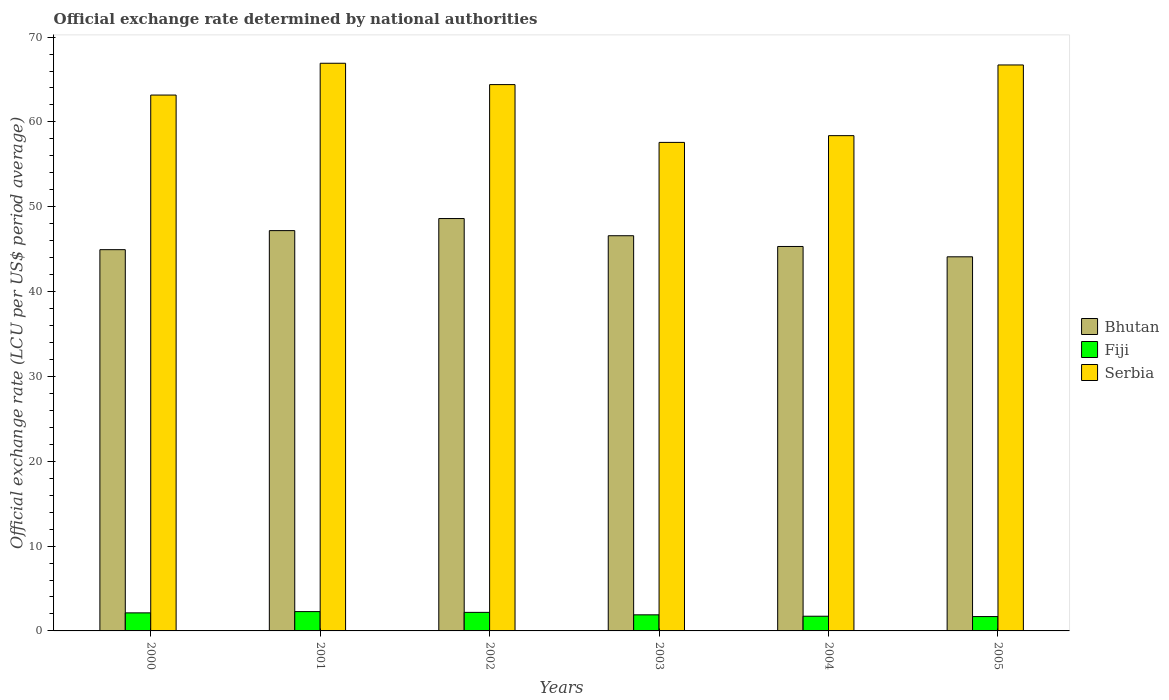How many bars are there on the 3rd tick from the left?
Offer a very short reply. 3. How many bars are there on the 5th tick from the right?
Provide a succinct answer. 3. What is the label of the 3rd group of bars from the left?
Keep it short and to the point. 2002. In how many cases, is the number of bars for a given year not equal to the number of legend labels?
Give a very brief answer. 0. What is the official exchange rate in Fiji in 2004?
Your answer should be very brief. 1.73. Across all years, what is the maximum official exchange rate in Serbia?
Your answer should be very brief. 66.91. Across all years, what is the minimum official exchange rate in Bhutan?
Make the answer very short. 44.1. In which year was the official exchange rate in Serbia maximum?
Your answer should be compact. 2001. What is the total official exchange rate in Serbia in the graph?
Ensure brevity in your answer.  377.16. What is the difference between the official exchange rate in Bhutan in 2002 and that in 2005?
Offer a terse response. 4.51. What is the difference between the official exchange rate in Serbia in 2005 and the official exchange rate in Fiji in 2004?
Your response must be concise. 64.98. What is the average official exchange rate in Serbia per year?
Give a very brief answer. 62.86. In the year 2001, what is the difference between the official exchange rate in Serbia and official exchange rate in Fiji?
Offer a very short reply. 64.64. In how many years, is the official exchange rate in Fiji greater than 18 LCU?
Offer a very short reply. 0. What is the ratio of the official exchange rate in Serbia in 2000 to that in 2005?
Give a very brief answer. 0.95. Is the official exchange rate in Serbia in 2000 less than that in 2004?
Your answer should be very brief. No. Is the difference between the official exchange rate in Serbia in 2000 and 2001 greater than the difference between the official exchange rate in Fiji in 2000 and 2001?
Provide a succinct answer. No. What is the difference between the highest and the second highest official exchange rate in Bhutan?
Your answer should be compact. 1.42. What is the difference between the highest and the lowest official exchange rate in Bhutan?
Ensure brevity in your answer.  4.51. In how many years, is the official exchange rate in Fiji greater than the average official exchange rate in Fiji taken over all years?
Your response must be concise. 3. Is the sum of the official exchange rate in Bhutan in 2003 and 2004 greater than the maximum official exchange rate in Serbia across all years?
Provide a short and direct response. Yes. What does the 2nd bar from the left in 2002 represents?
Keep it short and to the point. Fiji. What does the 2nd bar from the right in 2005 represents?
Your response must be concise. Fiji. What is the difference between two consecutive major ticks on the Y-axis?
Your answer should be very brief. 10. How many legend labels are there?
Provide a succinct answer. 3. What is the title of the graph?
Offer a terse response. Official exchange rate determined by national authorities. What is the label or title of the Y-axis?
Your answer should be compact. Official exchange rate (LCU per US$ period average). What is the Official exchange rate (LCU per US$ period average) in Bhutan in 2000?
Ensure brevity in your answer.  44.94. What is the Official exchange rate (LCU per US$ period average) in Fiji in 2000?
Offer a very short reply. 2.13. What is the Official exchange rate (LCU per US$ period average) of Serbia in 2000?
Provide a short and direct response. 63.17. What is the Official exchange rate (LCU per US$ period average) of Bhutan in 2001?
Ensure brevity in your answer.  47.19. What is the Official exchange rate (LCU per US$ period average) in Fiji in 2001?
Offer a terse response. 2.28. What is the Official exchange rate (LCU per US$ period average) in Serbia in 2001?
Provide a short and direct response. 66.91. What is the Official exchange rate (LCU per US$ period average) of Bhutan in 2002?
Your answer should be very brief. 48.61. What is the Official exchange rate (LCU per US$ period average) in Fiji in 2002?
Offer a terse response. 2.19. What is the Official exchange rate (LCU per US$ period average) of Serbia in 2002?
Ensure brevity in your answer.  64.4. What is the Official exchange rate (LCU per US$ period average) of Bhutan in 2003?
Offer a very short reply. 46.58. What is the Official exchange rate (LCU per US$ period average) in Fiji in 2003?
Your answer should be compact. 1.9. What is the Official exchange rate (LCU per US$ period average) of Serbia in 2003?
Your answer should be very brief. 57.59. What is the Official exchange rate (LCU per US$ period average) of Bhutan in 2004?
Keep it short and to the point. 45.32. What is the Official exchange rate (LCU per US$ period average) in Fiji in 2004?
Make the answer very short. 1.73. What is the Official exchange rate (LCU per US$ period average) of Serbia in 2004?
Ensure brevity in your answer.  58.38. What is the Official exchange rate (LCU per US$ period average) in Bhutan in 2005?
Provide a short and direct response. 44.1. What is the Official exchange rate (LCU per US$ period average) of Fiji in 2005?
Offer a very short reply. 1.69. What is the Official exchange rate (LCU per US$ period average) in Serbia in 2005?
Ensure brevity in your answer.  66.71. Across all years, what is the maximum Official exchange rate (LCU per US$ period average) of Bhutan?
Your response must be concise. 48.61. Across all years, what is the maximum Official exchange rate (LCU per US$ period average) of Fiji?
Your answer should be compact. 2.28. Across all years, what is the maximum Official exchange rate (LCU per US$ period average) in Serbia?
Give a very brief answer. 66.91. Across all years, what is the minimum Official exchange rate (LCU per US$ period average) of Bhutan?
Give a very brief answer. 44.1. Across all years, what is the minimum Official exchange rate (LCU per US$ period average) of Fiji?
Ensure brevity in your answer.  1.69. Across all years, what is the minimum Official exchange rate (LCU per US$ period average) of Serbia?
Your answer should be compact. 57.59. What is the total Official exchange rate (LCU per US$ period average) in Bhutan in the graph?
Give a very brief answer. 276.74. What is the total Official exchange rate (LCU per US$ period average) in Fiji in the graph?
Offer a terse response. 11.91. What is the total Official exchange rate (LCU per US$ period average) in Serbia in the graph?
Provide a short and direct response. 377.16. What is the difference between the Official exchange rate (LCU per US$ period average) in Bhutan in 2000 and that in 2001?
Your answer should be very brief. -2.24. What is the difference between the Official exchange rate (LCU per US$ period average) of Fiji in 2000 and that in 2001?
Keep it short and to the point. -0.15. What is the difference between the Official exchange rate (LCU per US$ period average) in Serbia in 2000 and that in 2001?
Make the answer very short. -3.75. What is the difference between the Official exchange rate (LCU per US$ period average) in Bhutan in 2000 and that in 2002?
Give a very brief answer. -3.67. What is the difference between the Official exchange rate (LCU per US$ period average) in Fiji in 2000 and that in 2002?
Your response must be concise. -0.06. What is the difference between the Official exchange rate (LCU per US$ period average) in Serbia in 2000 and that in 2002?
Your response must be concise. -1.23. What is the difference between the Official exchange rate (LCU per US$ period average) in Bhutan in 2000 and that in 2003?
Provide a short and direct response. -1.64. What is the difference between the Official exchange rate (LCU per US$ period average) of Fiji in 2000 and that in 2003?
Your answer should be compact. 0.23. What is the difference between the Official exchange rate (LCU per US$ period average) in Serbia in 2000 and that in 2003?
Offer a terse response. 5.58. What is the difference between the Official exchange rate (LCU per US$ period average) in Bhutan in 2000 and that in 2004?
Offer a terse response. -0.37. What is the difference between the Official exchange rate (LCU per US$ period average) in Fiji in 2000 and that in 2004?
Provide a succinct answer. 0.4. What is the difference between the Official exchange rate (LCU per US$ period average) in Serbia in 2000 and that in 2004?
Offer a terse response. 4.78. What is the difference between the Official exchange rate (LCU per US$ period average) of Bhutan in 2000 and that in 2005?
Give a very brief answer. 0.84. What is the difference between the Official exchange rate (LCU per US$ period average) of Fiji in 2000 and that in 2005?
Make the answer very short. 0.44. What is the difference between the Official exchange rate (LCU per US$ period average) of Serbia in 2000 and that in 2005?
Provide a short and direct response. -3.55. What is the difference between the Official exchange rate (LCU per US$ period average) of Bhutan in 2001 and that in 2002?
Offer a terse response. -1.42. What is the difference between the Official exchange rate (LCU per US$ period average) in Fiji in 2001 and that in 2002?
Keep it short and to the point. 0.09. What is the difference between the Official exchange rate (LCU per US$ period average) of Serbia in 2001 and that in 2002?
Offer a very short reply. 2.52. What is the difference between the Official exchange rate (LCU per US$ period average) in Bhutan in 2001 and that in 2003?
Your answer should be very brief. 0.6. What is the difference between the Official exchange rate (LCU per US$ period average) in Fiji in 2001 and that in 2003?
Your answer should be very brief. 0.38. What is the difference between the Official exchange rate (LCU per US$ period average) in Serbia in 2001 and that in 2003?
Keep it short and to the point. 9.33. What is the difference between the Official exchange rate (LCU per US$ period average) in Bhutan in 2001 and that in 2004?
Provide a short and direct response. 1.87. What is the difference between the Official exchange rate (LCU per US$ period average) in Fiji in 2001 and that in 2004?
Give a very brief answer. 0.54. What is the difference between the Official exchange rate (LCU per US$ period average) in Serbia in 2001 and that in 2004?
Provide a short and direct response. 8.53. What is the difference between the Official exchange rate (LCU per US$ period average) of Bhutan in 2001 and that in 2005?
Provide a short and direct response. 3.09. What is the difference between the Official exchange rate (LCU per US$ period average) of Fiji in 2001 and that in 2005?
Keep it short and to the point. 0.59. What is the difference between the Official exchange rate (LCU per US$ period average) in Serbia in 2001 and that in 2005?
Your response must be concise. 0.2. What is the difference between the Official exchange rate (LCU per US$ period average) in Bhutan in 2002 and that in 2003?
Provide a succinct answer. 2.03. What is the difference between the Official exchange rate (LCU per US$ period average) in Fiji in 2002 and that in 2003?
Ensure brevity in your answer.  0.29. What is the difference between the Official exchange rate (LCU per US$ period average) of Serbia in 2002 and that in 2003?
Offer a terse response. 6.81. What is the difference between the Official exchange rate (LCU per US$ period average) in Bhutan in 2002 and that in 2004?
Offer a terse response. 3.29. What is the difference between the Official exchange rate (LCU per US$ period average) of Fiji in 2002 and that in 2004?
Ensure brevity in your answer.  0.45. What is the difference between the Official exchange rate (LCU per US$ period average) of Serbia in 2002 and that in 2004?
Your response must be concise. 6.02. What is the difference between the Official exchange rate (LCU per US$ period average) of Bhutan in 2002 and that in 2005?
Offer a terse response. 4.51. What is the difference between the Official exchange rate (LCU per US$ period average) in Fiji in 2002 and that in 2005?
Offer a very short reply. 0.5. What is the difference between the Official exchange rate (LCU per US$ period average) of Serbia in 2002 and that in 2005?
Your response must be concise. -2.32. What is the difference between the Official exchange rate (LCU per US$ period average) in Bhutan in 2003 and that in 2004?
Provide a short and direct response. 1.27. What is the difference between the Official exchange rate (LCU per US$ period average) of Fiji in 2003 and that in 2004?
Offer a terse response. 0.16. What is the difference between the Official exchange rate (LCU per US$ period average) of Serbia in 2003 and that in 2004?
Provide a succinct answer. -0.8. What is the difference between the Official exchange rate (LCU per US$ period average) of Bhutan in 2003 and that in 2005?
Your answer should be very brief. 2.48. What is the difference between the Official exchange rate (LCU per US$ period average) in Fiji in 2003 and that in 2005?
Offer a very short reply. 0.2. What is the difference between the Official exchange rate (LCU per US$ period average) in Serbia in 2003 and that in 2005?
Provide a succinct answer. -9.13. What is the difference between the Official exchange rate (LCU per US$ period average) in Bhutan in 2004 and that in 2005?
Keep it short and to the point. 1.22. What is the difference between the Official exchange rate (LCU per US$ period average) in Fiji in 2004 and that in 2005?
Your answer should be very brief. 0.04. What is the difference between the Official exchange rate (LCU per US$ period average) in Serbia in 2004 and that in 2005?
Offer a very short reply. -8.33. What is the difference between the Official exchange rate (LCU per US$ period average) in Bhutan in 2000 and the Official exchange rate (LCU per US$ period average) in Fiji in 2001?
Offer a terse response. 42.66. What is the difference between the Official exchange rate (LCU per US$ period average) of Bhutan in 2000 and the Official exchange rate (LCU per US$ period average) of Serbia in 2001?
Offer a very short reply. -21.97. What is the difference between the Official exchange rate (LCU per US$ period average) of Fiji in 2000 and the Official exchange rate (LCU per US$ period average) of Serbia in 2001?
Your answer should be very brief. -64.78. What is the difference between the Official exchange rate (LCU per US$ period average) of Bhutan in 2000 and the Official exchange rate (LCU per US$ period average) of Fiji in 2002?
Your answer should be compact. 42.75. What is the difference between the Official exchange rate (LCU per US$ period average) in Bhutan in 2000 and the Official exchange rate (LCU per US$ period average) in Serbia in 2002?
Your response must be concise. -19.46. What is the difference between the Official exchange rate (LCU per US$ period average) in Fiji in 2000 and the Official exchange rate (LCU per US$ period average) in Serbia in 2002?
Keep it short and to the point. -62.27. What is the difference between the Official exchange rate (LCU per US$ period average) in Bhutan in 2000 and the Official exchange rate (LCU per US$ period average) in Fiji in 2003?
Give a very brief answer. 43.05. What is the difference between the Official exchange rate (LCU per US$ period average) of Bhutan in 2000 and the Official exchange rate (LCU per US$ period average) of Serbia in 2003?
Make the answer very short. -12.64. What is the difference between the Official exchange rate (LCU per US$ period average) of Fiji in 2000 and the Official exchange rate (LCU per US$ period average) of Serbia in 2003?
Your answer should be compact. -55.46. What is the difference between the Official exchange rate (LCU per US$ period average) of Bhutan in 2000 and the Official exchange rate (LCU per US$ period average) of Fiji in 2004?
Make the answer very short. 43.21. What is the difference between the Official exchange rate (LCU per US$ period average) of Bhutan in 2000 and the Official exchange rate (LCU per US$ period average) of Serbia in 2004?
Offer a very short reply. -13.44. What is the difference between the Official exchange rate (LCU per US$ period average) in Fiji in 2000 and the Official exchange rate (LCU per US$ period average) in Serbia in 2004?
Make the answer very short. -56.25. What is the difference between the Official exchange rate (LCU per US$ period average) in Bhutan in 2000 and the Official exchange rate (LCU per US$ period average) in Fiji in 2005?
Your answer should be very brief. 43.25. What is the difference between the Official exchange rate (LCU per US$ period average) in Bhutan in 2000 and the Official exchange rate (LCU per US$ period average) in Serbia in 2005?
Make the answer very short. -21.77. What is the difference between the Official exchange rate (LCU per US$ period average) in Fiji in 2000 and the Official exchange rate (LCU per US$ period average) in Serbia in 2005?
Make the answer very short. -64.59. What is the difference between the Official exchange rate (LCU per US$ period average) in Bhutan in 2001 and the Official exchange rate (LCU per US$ period average) in Fiji in 2002?
Give a very brief answer. 45. What is the difference between the Official exchange rate (LCU per US$ period average) of Bhutan in 2001 and the Official exchange rate (LCU per US$ period average) of Serbia in 2002?
Ensure brevity in your answer.  -17.21. What is the difference between the Official exchange rate (LCU per US$ period average) in Fiji in 2001 and the Official exchange rate (LCU per US$ period average) in Serbia in 2002?
Provide a succinct answer. -62.12. What is the difference between the Official exchange rate (LCU per US$ period average) in Bhutan in 2001 and the Official exchange rate (LCU per US$ period average) in Fiji in 2003?
Make the answer very short. 45.29. What is the difference between the Official exchange rate (LCU per US$ period average) of Bhutan in 2001 and the Official exchange rate (LCU per US$ period average) of Serbia in 2003?
Your answer should be compact. -10.4. What is the difference between the Official exchange rate (LCU per US$ period average) in Fiji in 2001 and the Official exchange rate (LCU per US$ period average) in Serbia in 2003?
Provide a succinct answer. -55.31. What is the difference between the Official exchange rate (LCU per US$ period average) in Bhutan in 2001 and the Official exchange rate (LCU per US$ period average) in Fiji in 2004?
Your response must be concise. 45.45. What is the difference between the Official exchange rate (LCU per US$ period average) in Bhutan in 2001 and the Official exchange rate (LCU per US$ period average) in Serbia in 2004?
Your answer should be compact. -11.2. What is the difference between the Official exchange rate (LCU per US$ period average) of Fiji in 2001 and the Official exchange rate (LCU per US$ period average) of Serbia in 2004?
Make the answer very short. -56.1. What is the difference between the Official exchange rate (LCU per US$ period average) in Bhutan in 2001 and the Official exchange rate (LCU per US$ period average) in Fiji in 2005?
Provide a short and direct response. 45.5. What is the difference between the Official exchange rate (LCU per US$ period average) of Bhutan in 2001 and the Official exchange rate (LCU per US$ period average) of Serbia in 2005?
Offer a terse response. -19.53. What is the difference between the Official exchange rate (LCU per US$ period average) in Fiji in 2001 and the Official exchange rate (LCU per US$ period average) in Serbia in 2005?
Ensure brevity in your answer.  -64.44. What is the difference between the Official exchange rate (LCU per US$ period average) in Bhutan in 2002 and the Official exchange rate (LCU per US$ period average) in Fiji in 2003?
Give a very brief answer. 46.71. What is the difference between the Official exchange rate (LCU per US$ period average) of Bhutan in 2002 and the Official exchange rate (LCU per US$ period average) of Serbia in 2003?
Give a very brief answer. -8.98. What is the difference between the Official exchange rate (LCU per US$ period average) in Fiji in 2002 and the Official exchange rate (LCU per US$ period average) in Serbia in 2003?
Provide a short and direct response. -55.4. What is the difference between the Official exchange rate (LCU per US$ period average) in Bhutan in 2002 and the Official exchange rate (LCU per US$ period average) in Fiji in 2004?
Provide a short and direct response. 46.88. What is the difference between the Official exchange rate (LCU per US$ period average) of Bhutan in 2002 and the Official exchange rate (LCU per US$ period average) of Serbia in 2004?
Offer a very short reply. -9.77. What is the difference between the Official exchange rate (LCU per US$ period average) of Fiji in 2002 and the Official exchange rate (LCU per US$ period average) of Serbia in 2004?
Ensure brevity in your answer.  -56.19. What is the difference between the Official exchange rate (LCU per US$ period average) in Bhutan in 2002 and the Official exchange rate (LCU per US$ period average) in Fiji in 2005?
Give a very brief answer. 46.92. What is the difference between the Official exchange rate (LCU per US$ period average) of Bhutan in 2002 and the Official exchange rate (LCU per US$ period average) of Serbia in 2005?
Your answer should be compact. -18.1. What is the difference between the Official exchange rate (LCU per US$ period average) in Fiji in 2002 and the Official exchange rate (LCU per US$ period average) in Serbia in 2005?
Offer a very short reply. -64.53. What is the difference between the Official exchange rate (LCU per US$ period average) of Bhutan in 2003 and the Official exchange rate (LCU per US$ period average) of Fiji in 2004?
Keep it short and to the point. 44.85. What is the difference between the Official exchange rate (LCU per US$ period average) in Bhutan in 2003 and the Official exchange rate (LCU per US$ period average) in Serbia in 2004?
Your answer should be very brief. -11.8. What is the difference between the Official exchange rate (LCU per US$ period average) of Fiji in 2003 and the Official exchange rate (LCU per US$ period average) of Serbia in 2004?
Give a very brief answer. -56.49. What is the difference between the Official exchange rate (LCU per US$ period average) in Bhutan in 2003 and the Official exchange rate (LCU per US$ period average) in Fiji in 2005?
Provide a short and direct response. 44.89. What is the difference between the Official exchange rate (LCU per US$ period average) in Bhutan in 2003 and the Official exchange rate (LCU per US$ period average) in Serbia in 2005?
Give a very brief answer. -20.13. What is the difference between the Official exchange rate (LCU per US$ period average) of Fiji in 2003 and the Official exchange rate (LCU per US$ period average) of Serbia in 2005?
Offer a very short reply. -64.82. What is the difference between the Official exchange rate (LCU per US$ period average) of Bhutan in 2004 and the Official exchange rate (LCU per US$ period average) of Fiji in 2005?
Keep it short and to the point. 43.63. What is the difference between the Official exchange rate (LCU per US$ period average) of Bhutan in 2004 and the Official exchange rate (LCU per US$ period average) of Serbia in 2005?
Offer a terse response. -21.4. What is the difference between the Official exchange rate (LCU per US$ period average) of Fiji in 2004 and the Official exchange rate (LCU per US$ period average) of Serbia in 2005?
Your response must be concise. -64.98. What is the average Official exchange rate (LCU per US$ period average) in Bhutan per year?
Keep it short and to the point. 46.12. What is the average Official exchange rate (LCU per US$ period average) of Fiji per year?
Keep it short and to the point. 1.99. What is the average Official exchange rate (LCU per US$ period average) of Serbia per year?
Ensure brevity in your answer.  62.86. In the year 2000, what is the difference between the Official exchange rate (LCU per US$ period average) in Bhutan and Official exchange rate (LCU per US$ period average) in Fiji?
Provide a short and direct response. 42.81. In the year 2000, what is the difference between the Official exchange rate (LCU per US$ period average) in Bhutan and Official exchange rate (LCU per US$ period average) in Serbia?
Your answer should be compact. -18.22. In the year 2000, what is the difference between the Official exchange rate (LCU per US$ period average) of Fiji and Official exchange rate (LCU per US$ period average) of Serbia?
Offer a very short reply. -61.04. In the year 2001, what is the difference between the Official exchange rate (LCU per US$ period average) of Bhutan and Official exchange rate (LCU per US$ period average) of Fiji?
Keep it short and to the point. 44.91. In the year 2001, what is the difference between the Official exchange rate (LCU per US$ period average) of Bhutan and Official exchange rate (LCU per US$ period average) of Serbia?
Give a very brief answer. -19.73. In the year 2001, what is the difference between the Official exchange rate (LCU per US$ period average) of Fiji and Official exchange rate (LCU per US$ period average) of Serbia?
Make the answer very short. -64.64. In the year 2002, what is the difference between the Official exchange rate (LCU per US$ period average) in Bhutan and Official exchange rate (LCU per US$ period average) in Fiji?
Keep it short and to the point. 46.42. In the year 2002, what is the difference between the Official exchange rate (LCU per US$ period average) in Bhutan and Official exchange rate (LCU per US$ period average) in Serbia?
Your answer should be very brief. -15.79. In the year 2002, what is the difference between the Official exchange rate (LCU per US$ period average) of Fiji and Official exchange rate (LCU per US$ period average) of Serbia?
Give a very brief answer. -62.21. In the year 2003, what is the difference between the Official exchange rate (LCU per US$ period average) in Bhutan and Official exchange rate (LCU per US$ period average) in Fiji?
Your response must be concise. 44.69. In the year 2003, what is the difference between the Official exchange rate (LCU per US$ period average) of Bhutan and Official exchange rate (LCU per US$ period average) of Serbia?
Give a very brief answer. -11. In the year 2003, what is the difference between the Official exchange rate (LCU per US$ period average) in Fiji and Official exchange rate (LCU per US$ period average) in Serbia?
Keep it short and to the point. -55.69. In the year 2004, what is the difference between the Official exchange rate (LCU per US$ period average) in Bhutan and Official exchange rate (LCU per US$ period average) in Fiji?
Offer a terse response. 43.58. In the year 2004, what is the difference between the Official exchange rate (LCU per US$ period average) of Bhutan and Official exchange rate (LCU per US$ period average) of Serbia?
Offer a terse response. -13.06. In the year 2004, what is the difference between the Official exchange rate (LCU per US$ period average) of Fiji and Official exchange rate (LCU per US$ period average) of Serbia?
Make the answer very short. -56.65. In the year 2005, what is the difference between the Official exchange rate (LCU per US$ period average) of Bhutan and Official exchange rate (LCU per US$ period average) of Fiji?
Give a very brief answer. 42.41. In the year 2005, what is the difference between the Official exchange rate (LCU per US$ period average) of Bhutan and Official exchange rate (LCU per US$ period average) of Serbia?
Your answer should be very brief. -22.61. In the year 2005, what is the difference between the Official exchange rate (LCU per US$ period average) of Fiji and Official exchange rate (LCU per US$ period average) of Serbia?
Provide a succinct answer. -65.02. What is the ratio of the Official exchange rate (LCU per US$ period average) in Fiji in 2000 to that in 2001?
Give a very brief answer. 0.94. What is the ratio of the Official exchange rate (LCU per US$ period average) in Serbia in 2000 to that in 2001?
Your answer should be compact. 0.94. What is the ratio of the Official exchange rate (LCU per US$ period average) of Bhutan in 2000 to that in 2002?
Offer a very short reply. 0.92. What is the ratio of the Official exchange rate (LCU per US$ period average) of Fiji in 2000 to that in 2002?
Give a very brief answer. 0.97. What is the ratio of the Official exchange rate (LCU per US$ period average) of Serbia in 2000 to that in 2002?
Make the answer very short. 0.98. What is the ratio of the Official exchange rate (LCU per US$ period average) of Bhutan in 2000 to that in 2003?
Your response must be concise. 0.96. What is the ratio of the Official exchange rate (LCU per US$ period average) in Fiji in 2000 to that in 2003?
Provide a short and direct response. 1.12. What is the ratio of the Official exchange rate (LCU per US$ period average) of Serbia in 2000 to that in 2003?
Give a very brief answer. 1.1. What is the ratio of the Official exchange rate (LCU per US$ period average) of Fiji in 2000 to that in 2004?
Offer a terse response. 1.23. What is the ratio of the Official exchange rate (LCU per US$ period average) of Serbia in 2000 to that in 2004?
Your answer should be compact. 1.08. What is the ratio of the Official exchange rate (LCU per US$ period average) in Bhutan in 2000 to that in 2005?
Offer a terse response. 1.02. What is the ratio of the Official exchange rate (LCU per US$ period average) in Fiji in 2000 to that in 2005?
Keep it short and to the point. 1.26. What is the ratio of the Official exchange rate (LCU per US$ period average) of Serbia in 2000 to that in 2005?
Your answer should be very brief. 0.95. What is the ratio of the Official exchange rate (LCU per US$ period average) of Bhutan in 2001 to that in 2002?
Make the answer very short. 0.97. What is the ratio of the Official exchange rate (LCU per US$ period average) in Fiji in 2001 to that in 2002?
Your answer should be very brief. 1.04. What is the ratio of the Official exchange rate (LCU per US$ period average) of Serbia in 2001 to that in 2002?
Ensure brevity in your answer.  1.04. What is the ratio of the Official exchange rate (LCU per US$ period average) of Bhutan in 2001 to that in 2003?
Keep it short and to the point. 1.01. What is the ratio of the Official exchange rate (LCU per US$ period average) of Fiji in 2001 to that in 2003?
Give a very brief answer. 1.2. What is the ratio of the Official exchange rate (LCU per US$ period average) in Serbia in 2001 to that in 2003?
Your response must be concise. 1.16. What is the ratio of the Official exchange rate (LCU per US$ period average) of Bhutan in 2001 to that in 2004?
Your answer should be compact. 1.04. What is the ratio of the Official exchange rate (LCU per US$ period average) in Fiji in 2001 to that in 2004?
Ensure brevity in your answer.  1.31. What is the ratio of the Official exchange rate (LCU per US$ period average) of Serbia in 2001 to that in 2004?
Make the answer very short. 1.15. What is the ratio of the Official exchange rate (LCU per US$ period average) in Bhutan in 2001 to that in 2005?
Keep it short and to the point. 1.07. What is the ratio of the Official exchange rate (LCU per US$ period average) of Fiji in 2001 to that in 2005?
Give a very brief answer. 1.35. What is the ratio of the Official exchange rate (LCU per US$ period average) in Bhutan in 2002 to that in 2003?
Give a very brief answer. 1.04. What is the ratio of the Official exchange rate (LCU per US$ period average) of Fiji in 2002 to that in 2003?
Make the answer very short. 1.15. What is the ratio of the Official exchange rate (LCU per US$ period average) of Serbia in 2002 to that in 2003?
Give a very brief answer. 1.12. What is the ratio of the Official exchange rate (LCU per US$ period average) of Bhutan in 2002 to that in 2004?
Your answer should be very brief. 1.07. What is the ratio of the Official exchange rate (LCU per US$ period average) of Fiji in 2002 to that in 2004?
Ensure brevity in your answer.  1.26. What is the ratio of the Official exchange rate (LCU per US$ period average) of Serbia in 2002 to that in 2004?
Ensure brevity in your answer.  1.1. What is the ratio of the Official exchange rate (LCU per US$ period average) in Bhutan in 2002 to that in 2005?
Your answer should be very brief. 1.1. What is the ratio of the Official exchange rate (LCU per US$ period average) of Fiji in 2002 to that in 2005?
Your response must be concise. 1.29. What is the ratio of the Official exchange rate (LCU per US$ period average) in Serbia in 2002 to that in 2005?
Offer a terse response. 0.97. What is the ratio of the Official exchange rate (LCU per US$ period average) in Bhutan in 2003 to that in 2004?
Offer a very short reply. 1.03. What is the ratio of the Official exchange rate (LCU per US$ period average) in Fiji in 2003 to that in 2004?
Ensure brevity in your answer.  1.09. What is the ratio of the Official exchange rate (LCU per US$ period average) in Serbia in 2003 to that in 2004?
Provide a succinct answer. 0.99. What is the ratio of the Official exchange rate (LCU per US$ period average) of Bhutan in 2003 to that in 2005?
Keep it short and to the point. 1.06. What is the ratio of the Official exchange rate (LCU per US$ period average) of Fiji in 2003 to that in 2005?
Offer a terse response. 1.12. What is the ratio of the Official exchange rate (LCU per US$ period average) in Serbia in 2003 to that in 2005?
Give a very brief answer. 0.86. What is the ratio of the Official exchange rate (LCU per US$ period average) in Bhutan in 2004 to that in 2005?
Provide a succinct answer. 1.03. What is the ratio of the Official exchange rate (LCU per US$ period average) of Fiji in 2004 to that in 2005?
Provide a succinct answer. 1.02. What is the ratio of the Official exchange rate (LCU per US$ period average) of Serbia in 2004 to that in 2005?
Offer a terse response. 0.88. What is the difference between the highest and the second highest Official exchange rate (LCU per US$ period average) of Bhutan?
Provide a short and direct response. 1.42. What is the difference between the highest and the second highest Official exchange rate (LCU per US$ period average) of Fiji?
Ensure brevity in your answer.  0.09. What is the difference between the highest and the second highest Official exchange rate (LCU per US$ period average) in Serbia?
Make the answer very short. 0.2. What is the difference between the highest and the lowest Official exchange rate (LCU per US$ period average) in Bhutan?
Provide a short and direct response. 4.51. What is the difference between the highest and the lowest Official exchange rate (LCU per US$ period average) of Fiji?
Make the answer very short. 0.59. What is the difference between the highest and the lowest Official exchange rate (LCU per US$ period average) in Serbia?
Offer a very short reply. 9.33. 